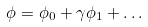<formula> <loc_0><loc_0><loc_500><loc_500>\phi = \phi _ { 0 } + \gamma \phi _ { 1 } + \dots</formula> 